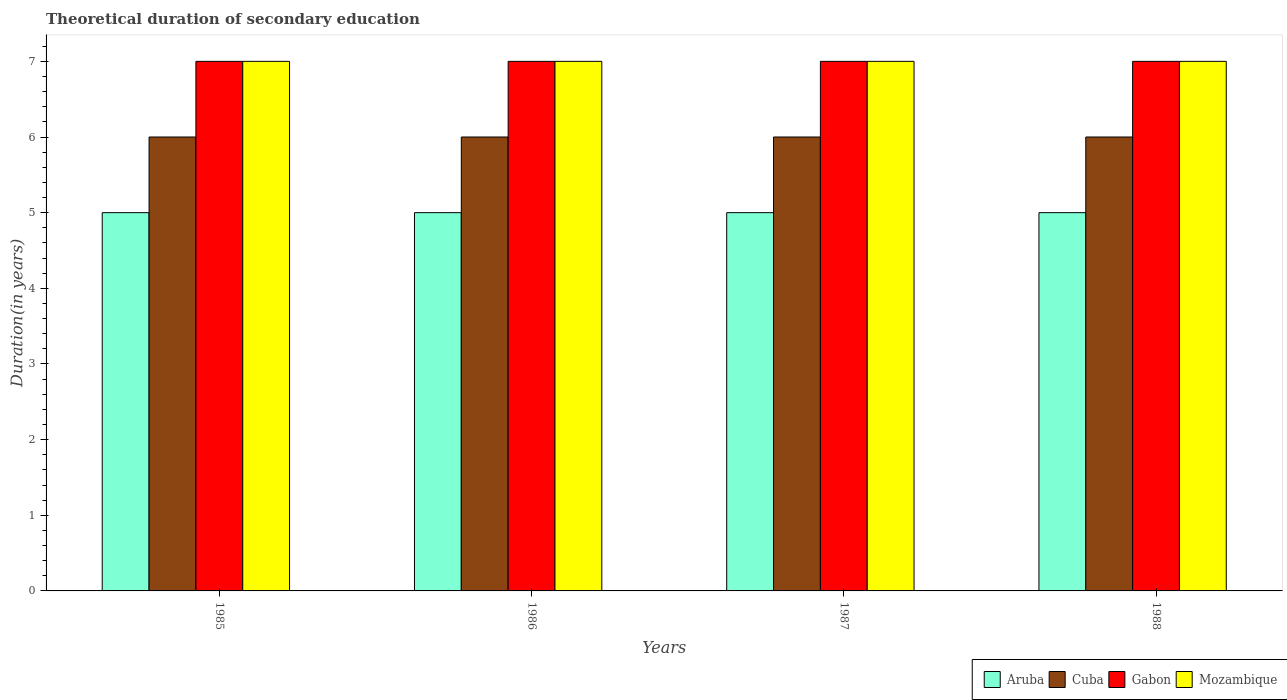How many groups of bars are there?
Ensure brevity in your answer.  4. Are the number of bars per tick equal to the number of legend labels?
Provide a succinct answer. Yes. Are the number of bars on each tick of the X-axis equal?
Provide a short and direct response. Yes. How many bars are there on the 2nd tick from the right?
Offer a very short reply. 4. What is the label of the 2nd group of bars from the left?
Offer a very short reply. 1986. What is the total theoretical duration of secondary education in Aruba in 1985?
Ensure brevity in your answer.  5. Across all years, what is the maximum total theoretical duration of secondary education in Aruba?
Provide a short and direct response. 5. Across all years, what is the minimum total theoretical duration of secondary education in Mozambique?
Offer a very short reply. 7. In which year was the total theoretical duration of secondary education in Cuba maximum?
Make the answer very short. 1985. In which year was the total theoretical duration of secondary education in Aruba minimum?
Provide a short and direct response. 1985. What is the total total theoretical duration of secondary education in Cuba in the graph?
Keep it short and to the point. 24. What is the difference between the total theoretical duration of secondary education in Mozambique in 1985 and that in 1987?
Your answer should be very brief. 0. What is the difference between the total theoretical duration of secondary education in Aruba in 1988 and the total theoretical duration of secondary education in Cuba in 1985?
Your answer should be very brief. -1. In the year 1986, what is the difference between the total theoretical duration of secondary education in Gabon and total theoretical duration of secondary education in Aruba?
Ensure brevity in your answer.  2. What is the ratio of the total theoretical duration of secondary education in Cuba in 1985 to that in 1988?
Give a very brief answer. 1. Is the difference between the total theoretical duration of secondary education in Gabon in 1986 and 1988 greater than the difference between the total theoretical duration of secondary education in Aruba in 1986 and 1988?
Keep it short and to the point. No. In how many years, is the total theoretical duration of secondary education in Mozambique greater than the average total theoretical duration of secondary education in Mozambique taken over all years?
Provide a short and direct response. 0. What does the 4th bar from the left in 1987 represents?
Provide a short and direct response. Mozambique. What does the 1st bar from the right in 1986 represents?
Make the answer very short. Mozambique. Is it the case that in every year, the sum of the total theoretical duration of secondary education in Aruba and total theoretical duration of secondary education in Cuba is greater than the total theoretical duration of secondary education in Mozambique?
Provide a succinct answer. Yes. How many bars are there?
Your answer should be compact. 16. Are all the bars in the graph horizontal?
Give a very brief answer. No. What is the difference between two consecutive major ticks on the Y-axis?
Keep it short and to the point. 1. Are the values on the major ticks of Y-axis written in scientific E-notation?
Ensure brevity in your answer.  No. How many legend labels are there?
Make the answer very short. 4. How are the legend labels stacked?
Ensure brevity in your answer.  Horizontal. What is the title of the graph?
Your answer should be very brief. Theoretical duration of secondary education. What is the label or title of the X-axis?
Your answer should be very brief. Years. What is the label or title of the Y-axis?
Offer a very short reply. Duration(in years). What is the Duration(in years) in Aruba in 1985?
Your response must be concise. 5. What is the Duration(in years) in Cuba in 1985?
Provide a short and direct response. 6. What is the Duration(in years) in Mozambique in 1985?
Your answer should be very brief. 7. What is the Duration(in years) of Aruba in 1986?
Keep it short and to the point. 5. What is the Duration(in years) of Cuba in 1986?
Provide a succinct answer. 6. What is the Duration(in years) in Gabon in 1986?
Ensure brevity in your answer.  7. What is the Duration(in years) in Aruba in 1987?
Provide a succinct answer. 5. What is the Duration(in years) in Gabon in 1987?
Offer a terse response. 7. What is the Duration(in years) of Mozambique in 1987?
Your response must be concise. 7. What is the Duration(in years) in Gabon in 1988?
Your response must be concise. 7. What is the Duration(in years) in Mozambique in 1988?
Your answer should be very brief. 7. Across all years, what is the maximum Duration(in years) of Gabon?
Make the answer very short. 7. Across all years, what is the minimum Duration(in years) of Gabon?
Your answer should be very brief. 7. What is the total Duration(in years) of Aruba in the graph?
Provide a short and direct response. 20. What is the total Duration(in years) in Gabon in the graph?
Make the answer very short. 28. What is the difference between the Duration(in years) in Cuba in 1985 and that in 1986?
Give a very brief answer. 0. What is the difference between the Duration(in years) in Gabon in 1985 and that in 1986?
Provide a succinct answer. 0. What is the difference between the Duration(in years) of Mozambique in 1985 and that in 1986?
Your response must be concise. 0. What is the difference between the Duration(in years) in Mozambique in 1985 and that in 1987?
Provide a succinct answer. 0. What is the difference between the Duration(in years) in Cuba in 1985 and that in 1988?
Your answer should be compact. 0. What is the difference between the Duration(in years) of Gabon in 1985 and that in 1988?
Give a very brief answer. 0. What is the difference between the Duration(in years) of Mozambique in 1985 and that in 1988?
Provide a succinct answer. 0. What is the difference between the Duration(in years) in Aruba in 1986 and that in 1987?
Give a very brief answer. 0. What is the difference between the Duration(in years) in Cuba in 1986 and that in 1987?
Ensure brevity in your answer.  0. What is the difference between the Duration(in years) of Gabon in 1986 and that in 1987?
Keep it short and to the point. 0. What is the difference between the Duration(in years) of Mozambique in 1986 and that in 1987?
Provide a succinct answer. 0. What is the difference between the Duration(in years) in Aruba in 1986 and that in 1988?
Your answer should be compact. 0. What is the difference between the Duration(in years) of Gabon in 1986 and that in 1988?
Provide a short and direct response. 0. What is the difference between the Duration(in years) in Mozambique in 1986 and that in 1988?
Ensure brevity in your answer.  0. What is the difference between the Duration(in years) of Cuba in 1987 and that in 1988?
Ensure brevity in your answer.  0. What is the difference between the Duration(in years) in Gabon in 1987 and that in 1988?
Make the answer very short. 0. What is the difference between the Duration(in years) of Aruba in 1985 and the Duration(in years) of Cuba in 1986?
Your response must be concise. -1. What is the difference between the Duration(in years) in Gabon in 1985 and the Duration(in years) in Mozambique in 1986?
Keep it short and to the point. 0. What is the difference between the Duration(in years) of Aruba in 1985 and the Duration(in years) of Cuba in 1987?
Provide a short and direct response. -1. What is the difference between the Duration(in years) in Aruba in 1985 and the Duration(in years) in Mozambique in 1987?
Provide a succinct answer. -2. What is the difference between the Duration(in years) in Cuba in 1985 and the Duration(in years) in Gabon in 1987?
Ensure brevity in your answer.  -1. What is the difference between the Duration(in years) of Gabon in 1985 and the Duration(in years) of Mozambique in 1987?
Provide a short and direct response. 0. What is the difference between the Duration(in years) in Aruba in 1985 and the Duration(in years) in Gabon in 1988?
Offer a very short reply. -2. What is the difference between the Duration(in years) in Cuba in 1985 and the Duration(in years) in Gabon in 1988?
Your answer should be compact. -1. What is the difference between the Duration(in years) of Cuba in 1985 and the Duration(in years) of Mozambique in 1988?
Give a very brief answer. -1. What is the difference between the Duration(in years) in Gabon in 1985 and the Duration(in years) in Mozambique in 1988?
Provide a succinct answer. 0. What is the difference between the Duration(in years) of Cuba in 1986 and the Duration(in years) of Gabon in 1987?
Your answer should be very brief. -1. What is the difference between the Duration(in years) of Aruba in 1986 and the Duration(in years) of Cuba in 1988?
Offer a terse response. -1. What is the difference between the Duration(in years) of Aruba in 1986 and the Duration(in years) of Gabon in 1988?
Provide a short and direct response. -2. What is the difference between the Duration(in years) in Cuba in 1986 and the Duration(in years) in Mozambique in 1988?
Make the answer very short. -1. What is the difference between the Duration(in years) in Gabon in 1986 and the Duration(in years) in Mozambique in 1988?
Make the answer very short. 0. What is the difference between the Duration(in years) in Aruba in 1987 and the Duration(in years) in Gabon in 1988?
Your answer should be compact. -2. What is the difference between the Duration(in years) of Cuba in 1987 and the Duration(in years) of Mozambique in 1988?
Ensure brevity in your answer.  -1. What is the average Duration(in years) in Aruba per year?
Your answer should be very brief. 5. What is the average Duration(in years) in Cuba per year?
Keep it short and to the point. 6. What is the average Duration(in years) of Mozambique per year?
Provide a short and direct response. 7. In the year 1985, what is the difference between the Duration(in years) in Aruba and Duration(in years) in Cuba?
Offer a terse response. -1. In the year 1985, what is the difference between the Duration(in years) of Cuba and Duration(in years) of Mozambique?
Your answer should be compact. -1. In the year 1985, what is the difference between the Duration(in years) in Gabon and Duration(in years) in Mozambique?
Provide a succinct answer. 0. In the year 1986, what is the difference between the Duration(in years) of Aruba and Duration(in years) of Cuba?
Your response must be concise. -1. In the year 1986, what is the difference between the Duration(in years) of Cuba and Duration(in years) of Gabon?
Your answer should be very brief. -1. In the year 1986, what is the difference between the Duration(in years) in Cuba and Duration(in years) in Mozambique?
Provide a succinct answer. -1. In the year 1986, what is the difference between the Duration(in years) in Gabon and Duration(in years) in Mozambique?
Make the answer very short. 0. In the year 1987, what is the difference between the Duration(in years) of Aruba and Duration(in years) of Cuba?
Provide a succinct answer. -1. In the year 1987, what is the difference between the Duration(in years) in Aruba and Duration(in years) in Gabon?
Your response must be concise. -2. In the year 1987, what is the difference between the Duration(in years) in Aruba and Duration(in years) in Mozambique?
Provide a short and direct response. -2. In the year 1987, what is the difference between the Duration(in years) in Cuba and Duration(in years) in Gabon?
Your response must be concise. -1. In the year 1987, what is the difference between the Duration(in years) of Gabon and Duration(in years) of Mozambique?
Give a very brief answer. 0. In the year 1988, what is the difference between the Duration(in years) in Aruba and Duration(in years) in Mozambique?
Give a very brief answer. -2. In the year 1988, what is the difference between the Duration(in years) in Cuba and Duration(in years) in Gabon?
Provide a succinct answer. -1. In the year 1988, what is the difference between the Duration(in years) of Cuba and Duration(in years) of Mozambique?
Ensure brevity in your answer.  -1. What is the ratio of the Duration(in years) of Aruba in 1985 to that in 1986?
Your response must be concise. 1. What is the ratio of the Duration(in years) in Gabon in 1985 to that in 1986?
Give a very brief answer. 1. What is the ratio of the Duration(in years) in Mozambique in 1985 to that in 1986?
Provide a succinct answer. 1. What is the ratio of the Duration(in years) in Aruba in 1985 to that in 1987?
Ensure brevity in your answer.  1. What is the ratio of the Duration(in years) in Gabon in 1985 to that in 1987?
Make the answer very short. 1. What is the ratio of the Duration(in years) in Mozambique in 1985 to that in 1987?
Ensure brevity in your answer.  1. What is the ratio of the Duration(in years) of Cuba in 1985 to that in 1988?
Offer a terse response. 1. What is the ratio of the Duration(in years) of Mozambique in 1985 to that in 1988?
Make the answer very short. 1. What is the ratio of the Duration(in years) in Cuba in 1986 to that in 1987?
Your response must be concise. 1. What is the ratio of the Duration(in years) in Gabon in 1986 to that in 1987?
Make the answer very short. 1. What is the ratio of the Duration(in years) in Cuba in 1986 to that in 1988?
Offer a very short reply. 1. What is the ratio of the Duration(in years) of Gabon in 1986 to that in 1988?
Give a very brief answer. 1. What is the ratio of the Duration(in years) in Cuba in 1987 to that in 1988?
Your answer should be very brief. 1. What is the ratio of the Duration(in years) of Gabon in 1987 to that in 1988?
Ensure brevity in your answer.  1. What is the ratio of the Duration(in years) of Mozambique in 1987 to that in 1988?
Make the answer very short. 1. What is the difference between the highest and the second highest Duration(in years) of Aruba?
Provide a succinct answer. 0. What is the difference between the highest and the second highest Duration(in years) of Gabon?
Your answer should be very brief. 0. What is the difference between the highest and the second highest Duration(in years) of Mozambique?
Offer a very short reply. 0. What is the difference between the highest and the lowest Duration(in years) in Gabon?
Provide a succinct answer. 0. What is the difference between the highest and the lowest Duration(in years) in Mozambique?
Your answer should be very brief. 0. 